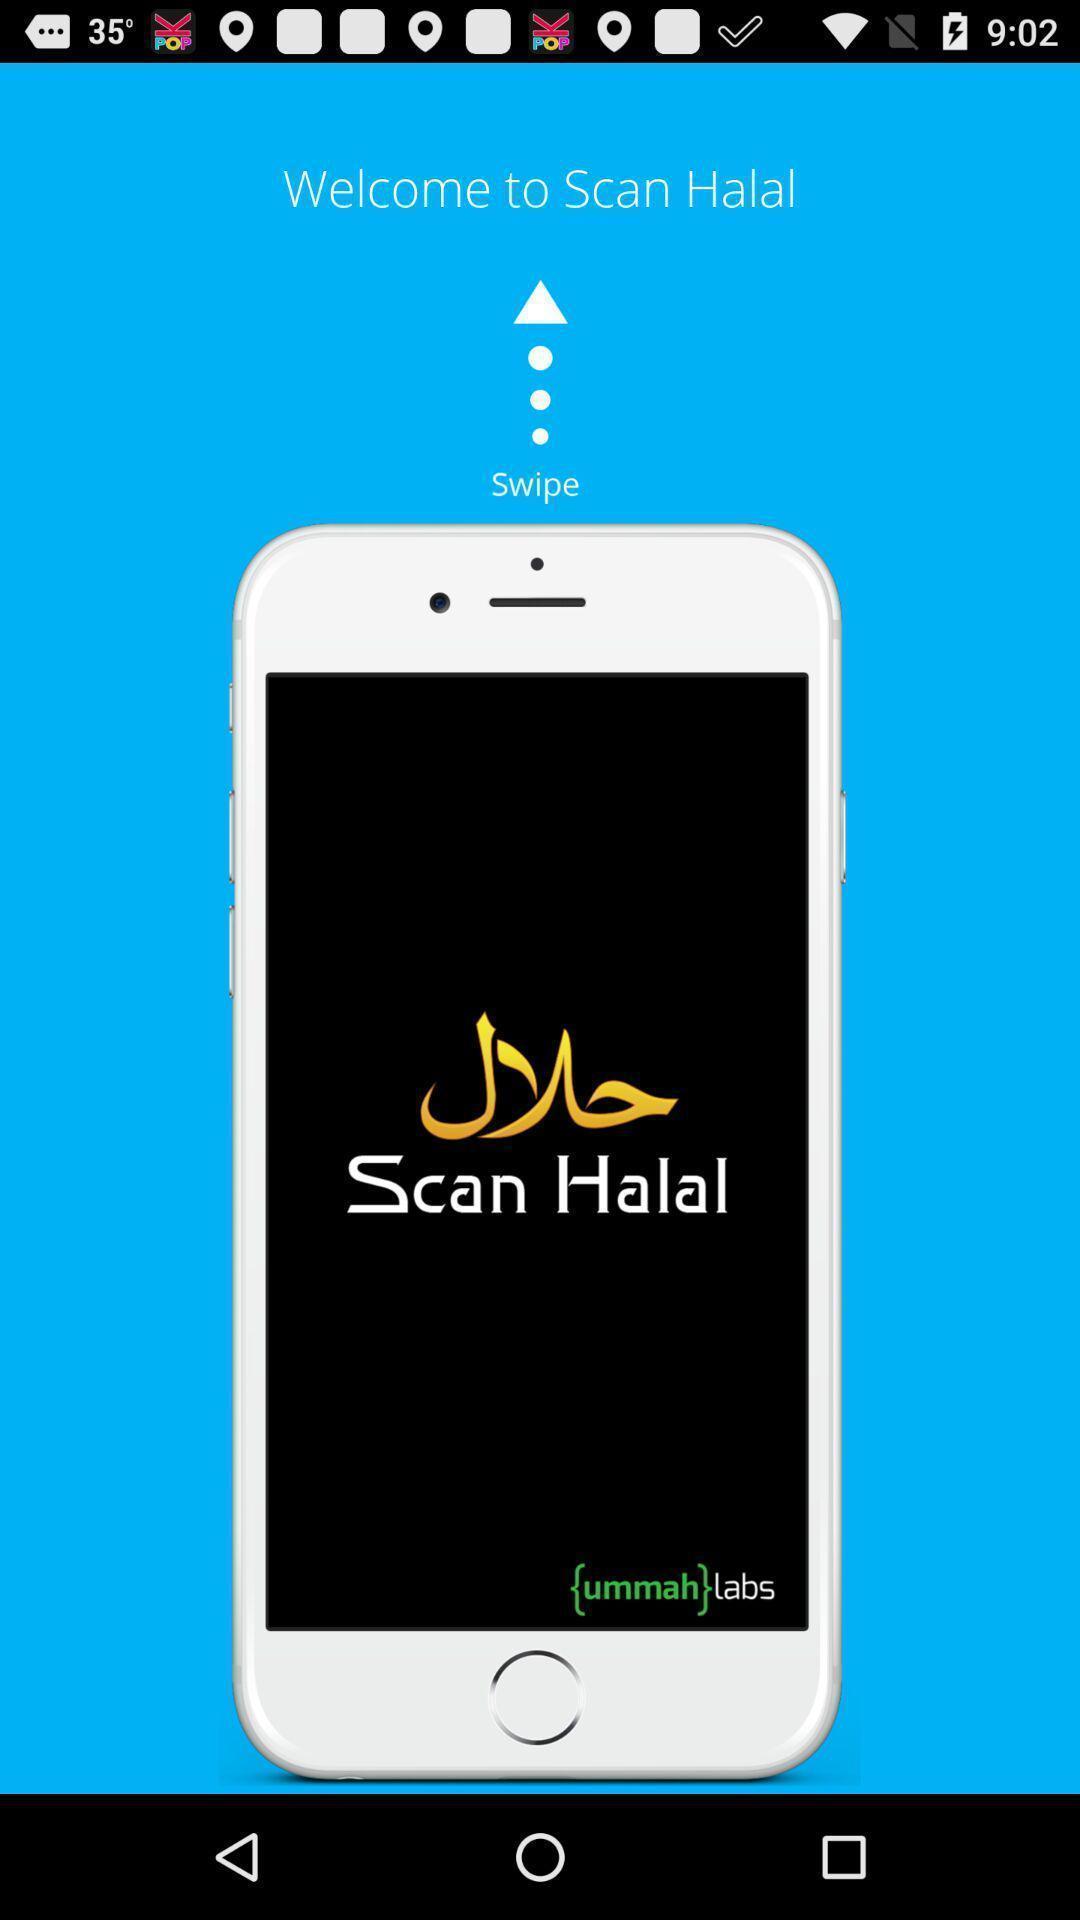Tell me what you see in this picture. Welcome page to the application. 